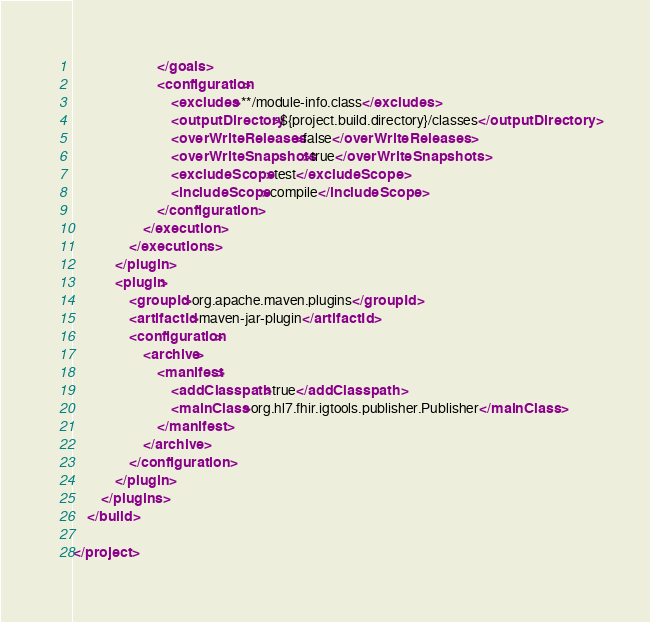<code> <loc_0><loc_0><loc_500><loc_500><_XML_>                        </goals>
                        <configuration>
                            <excludes>**/module-info.class</excludes>
                            <outputDirectory>${project.build.directory}/classes</outputDirectory>
                            <overWriteReleases>false</overWriteReleases>
                            <overWriteSnapshots>true</overWriteSnapshots>
                            <excludeScope>test</excludeScope>
                            <includeScope>compile</includeScope>
                        </configuration>
                    </execution>
                </executions>
            </plugin>
            <plugin>
                <groupId>org.apache.maven.plugins</groupId>
                <artifactId>maven-jar-plugin</artifactId>
                <configuration>
                    <archive>
                        <manifest>
                            <addClasspath>true</addClasspath>
                            <mainClass>org.hl7.fhir.igtools.publisher.Publisher</mainClass>
                        </manifest>
                    </archive>
                </configuration>
            </plugin>
        </plugins>
    </build>

</project></code> 